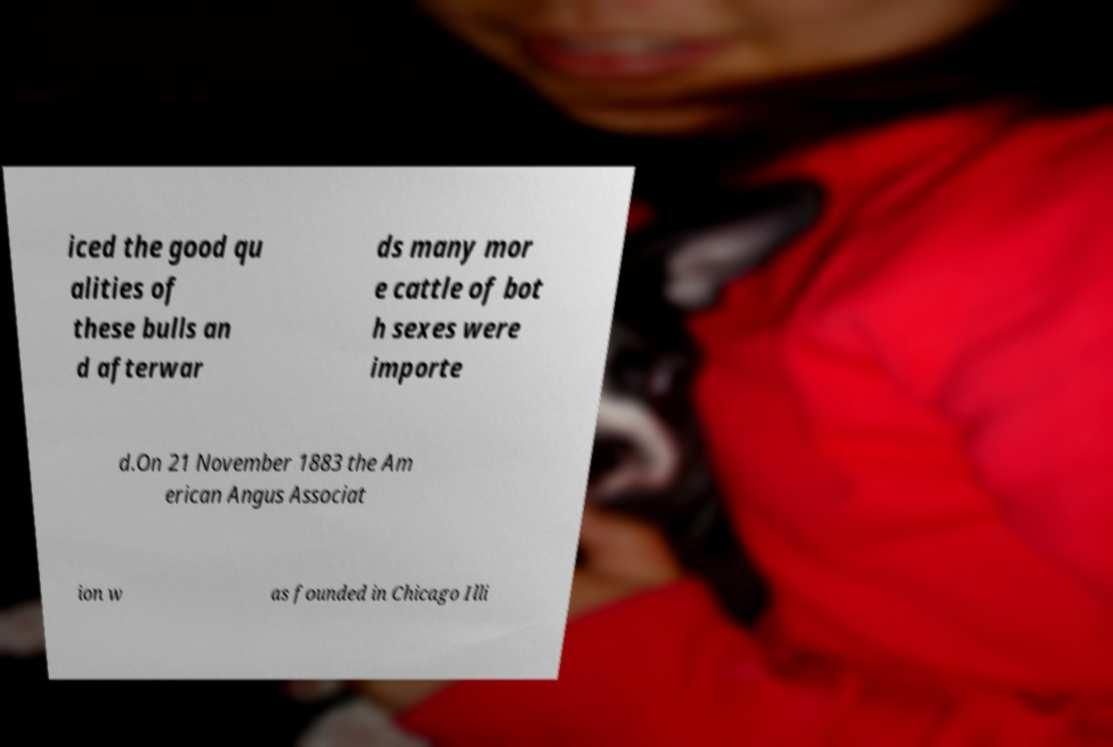What messages or text are displayed in this image? I need them in a readable, typed format. iced the good qu alities of these bulls an d afterwar ds many mor e cattle of bot h sexes were importe d.On 21 November 1883 the Am erican Angus Associat ion w as founded in Chicago Illi 